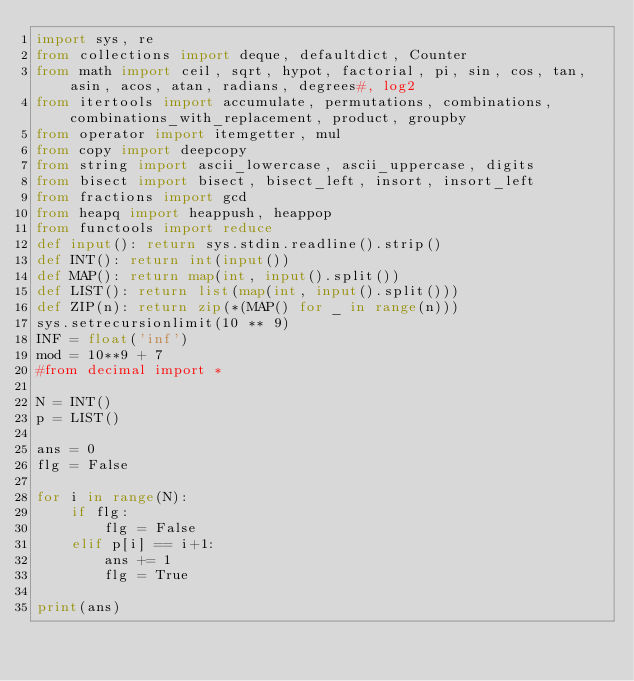<code> <loc_0><loc_0><loc_500><loc_500><_Python_>import sys, re
from collections import deque, defaultdict, Counter
from math import ceil, sqrt, hypot, factorial, pi, sin, cos, tan, asin, acos, atan, radians, degrees#, log2
from itertools import accumulate, permutations, combinations, combinations_with_replacement, product, groupby
from operator import itemgetter, mul
from copy import deepcopy
from string import ascii_lowercase, ascii_uppercase, digits
from bisect import bisect, bisect_left, insort, insort_left
from fractions import gcd
from heapq import heappush, heappop
from functools import reduce
def input(): return sys.stdin.readline().strip()
def INT(): return int(input())
def MAP(): return map(int, input().split())
def LIST(): return list(map(int, input().split()))
def ZIP(n): return zip(*(MAP() for _ in range(n)))
sys.setrecursionlimit(10 ** 9)
INF = float('inf')
mod = 10**9 + 7
#from decimal import *

N = INT()
p = LIST()

ans = 0
flg = False

for i in range(N):
	if flg:
		flg = False
	elif p[i] == i+1:
		ans += 1
		flg = True

print(ans)


</code> 